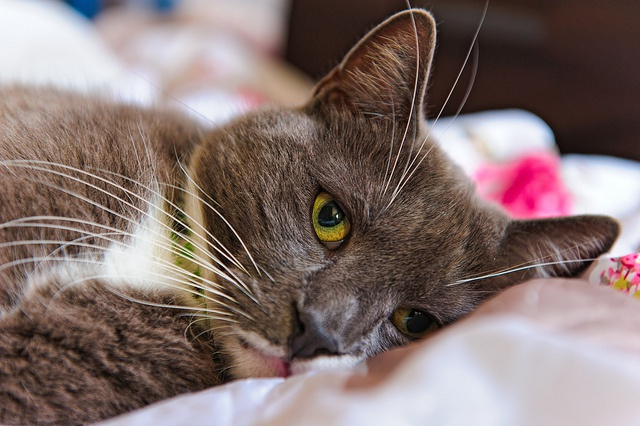Describe the objects in this image and their specific colors. I can see cat in white, gray, maroon, and black tones and bed in white, lightgray, darkgray, and pink tones in this image. 